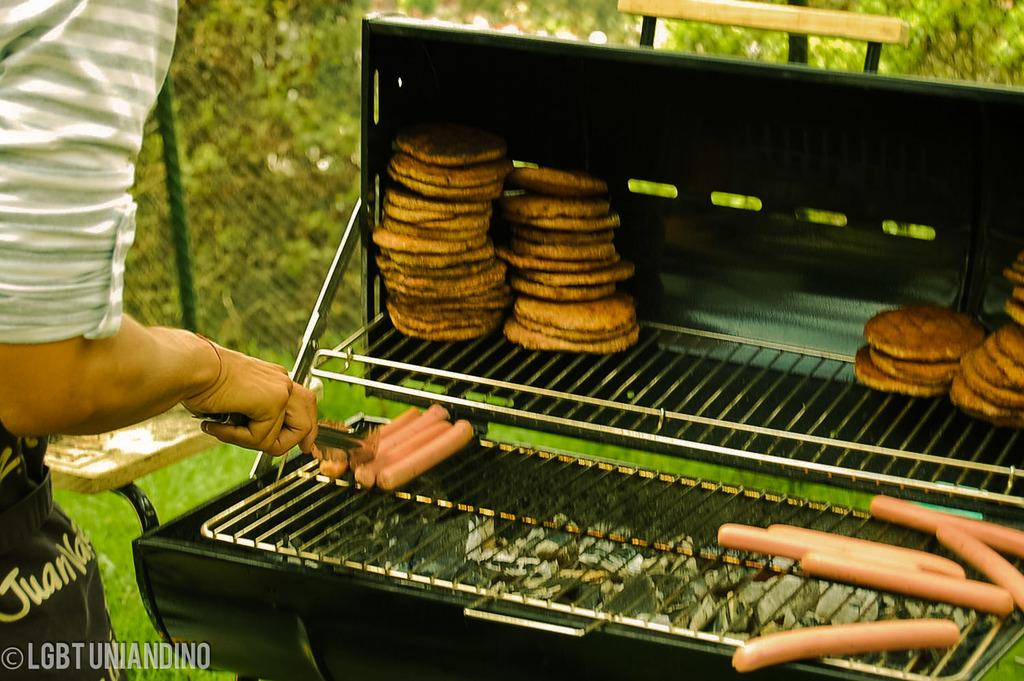What is being cooked on the barbecue in the image? There are food items on the barbecue in the image. What might be used for serving food in the image? There are plates visible in the image. What type of barrier can be seen in the image? There is fencing in the image. What tool is the person holding in the image? The person is holding a tong in the image. What type of curve can be seen in the image? There is no curve present in the image. Is there a bear visible in the image? No, there is no bear present in the image. 